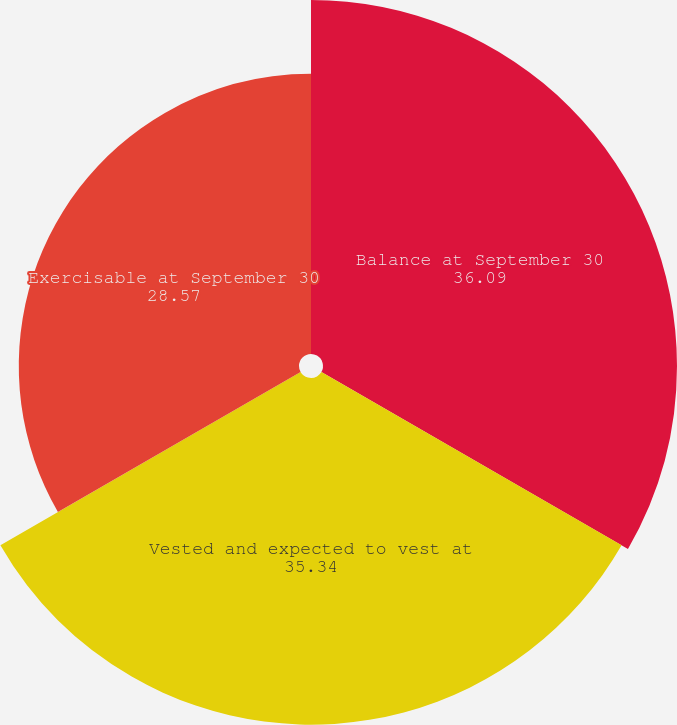Convert chart to OTSL. <chart><loc_0><loc_0><loc_500><loc_500><pie_chart><fcel>Balance at September 30<fcel>Vested and expected to vest at<fcel>Exercisable at September 30<nl><fcel>36.09%<fcel>35.34%<fcel>28.57%<nl></chart> 